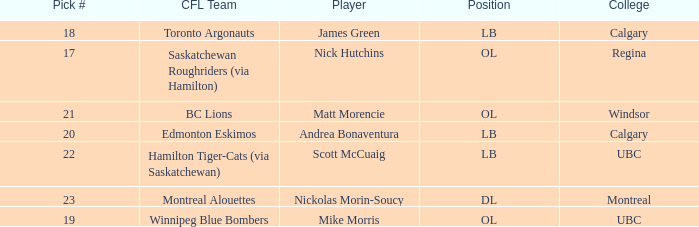Which player is on the BC Lions?  Matt Morencie. 